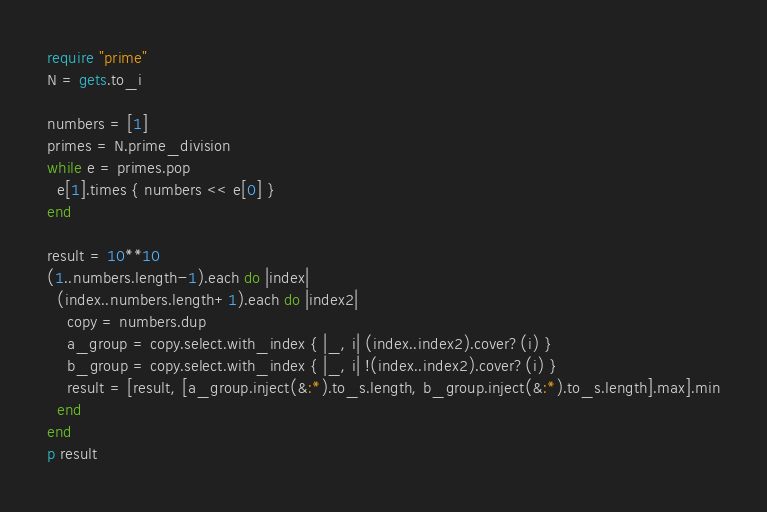<code> <loc_0><loc_0><loc_500><loc_500><_Ruby_>require "prime"
N = gets.to_i

numbers = [1]
primes = N.prime_division
while e = primes.pop
  e[1].times { numbers << e[0] }
end

result = 10**10
(1..numbers.length-1).each do |index|
  (index..numbers.length+1).each do |index2|
    copy = numbers.dup
    a_group = copy.select.with_index { |_, i| (index..index2).cover?(i) }
    b_group = copy.select.with_index { |_, i| !(index..index2).cover?(i) }
    result = [result, [a_group.inject(&:*).to_s.length, b_group.inject(&:*).to_s.length].max].min
  end
end
p result</code> 